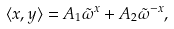Convert formula to latex. <formula><loc_0><loc_0><loc_500><loc_500>\langle x , y \rangle = A _ { 1 } \tilde { \omega } ^ { x } + A _ { 2 } \tilde { \omega } ^ { - x } ,</formula> 